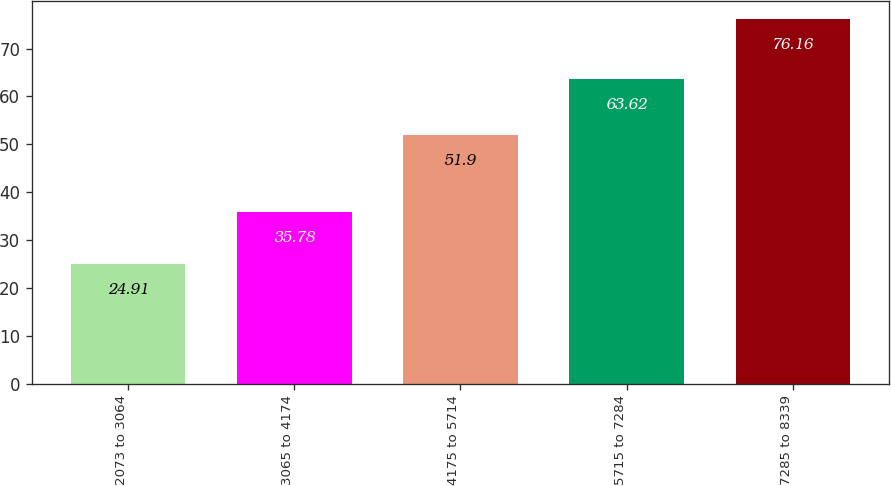<chart> <loc_0><loc_0><loc_500><loc_500><bar_chart><fcel>2073 to 3064<fcel>3065 to 4174<fcel>4175 to 5714<fcel>5715 to 7284<fcel>7285 to 8339<nl><fcel>24.91<fcel>35.78<fcel>51.9<fcel>63.62<fcel>76.16<nl></chart> 